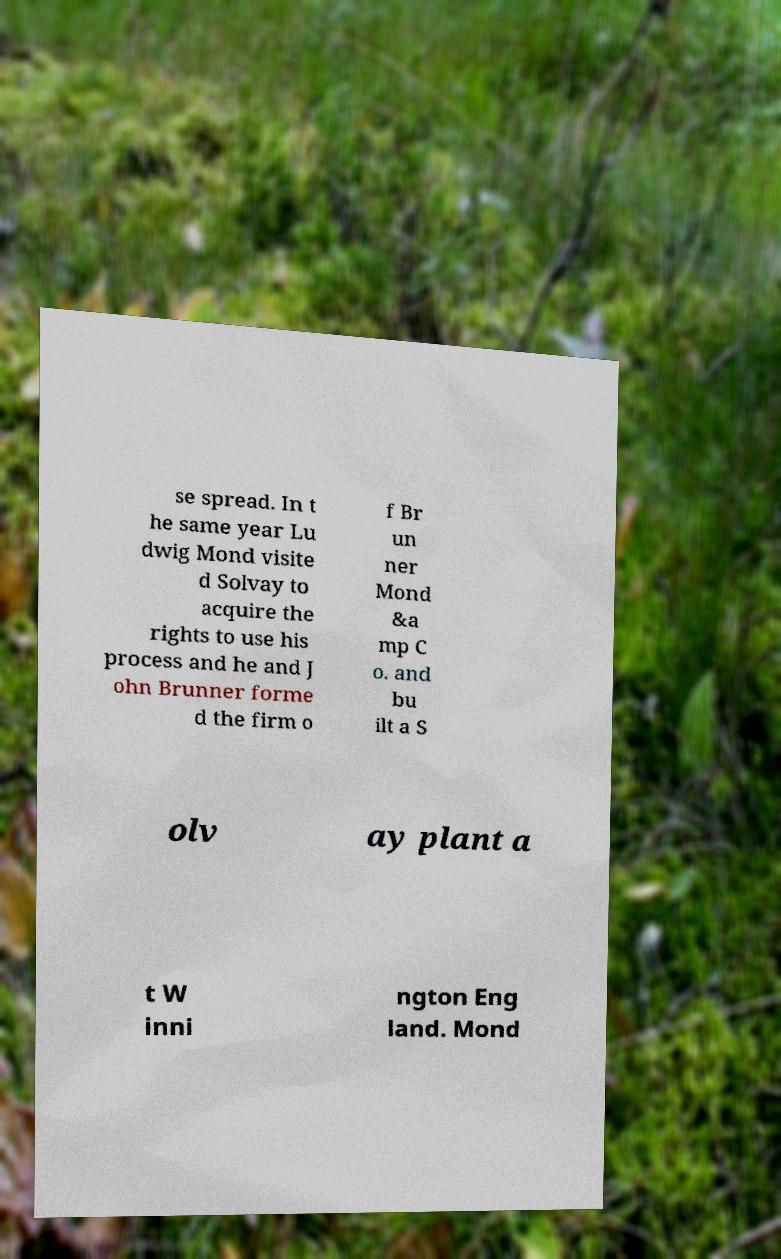There's text embedded in this image that I need extracted. Can you transcribe it verbatim? se spread. In t he same year Lu dwig Mond visite d Solvay to acquire the rights to use his process and he and J ohn Brunner forme d the firm o f Br un ner Mond &a mp C o. and bu ilt a S olv ay plant a t W inni ngton Eng land. Mond 